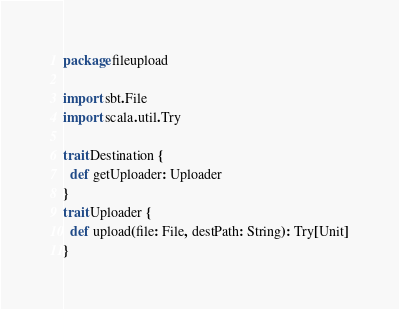Convert code to text. <code><loc_0><loc_0><loc_500><loc_500><_Scala_>package fileupload

import sbt.File
import scala.util.Try

trait Destination {
  def getUploader: Uploader
}
trait Uploader {
  def upload(file: File, destPath: String): Try[Unit]
}
</code> 